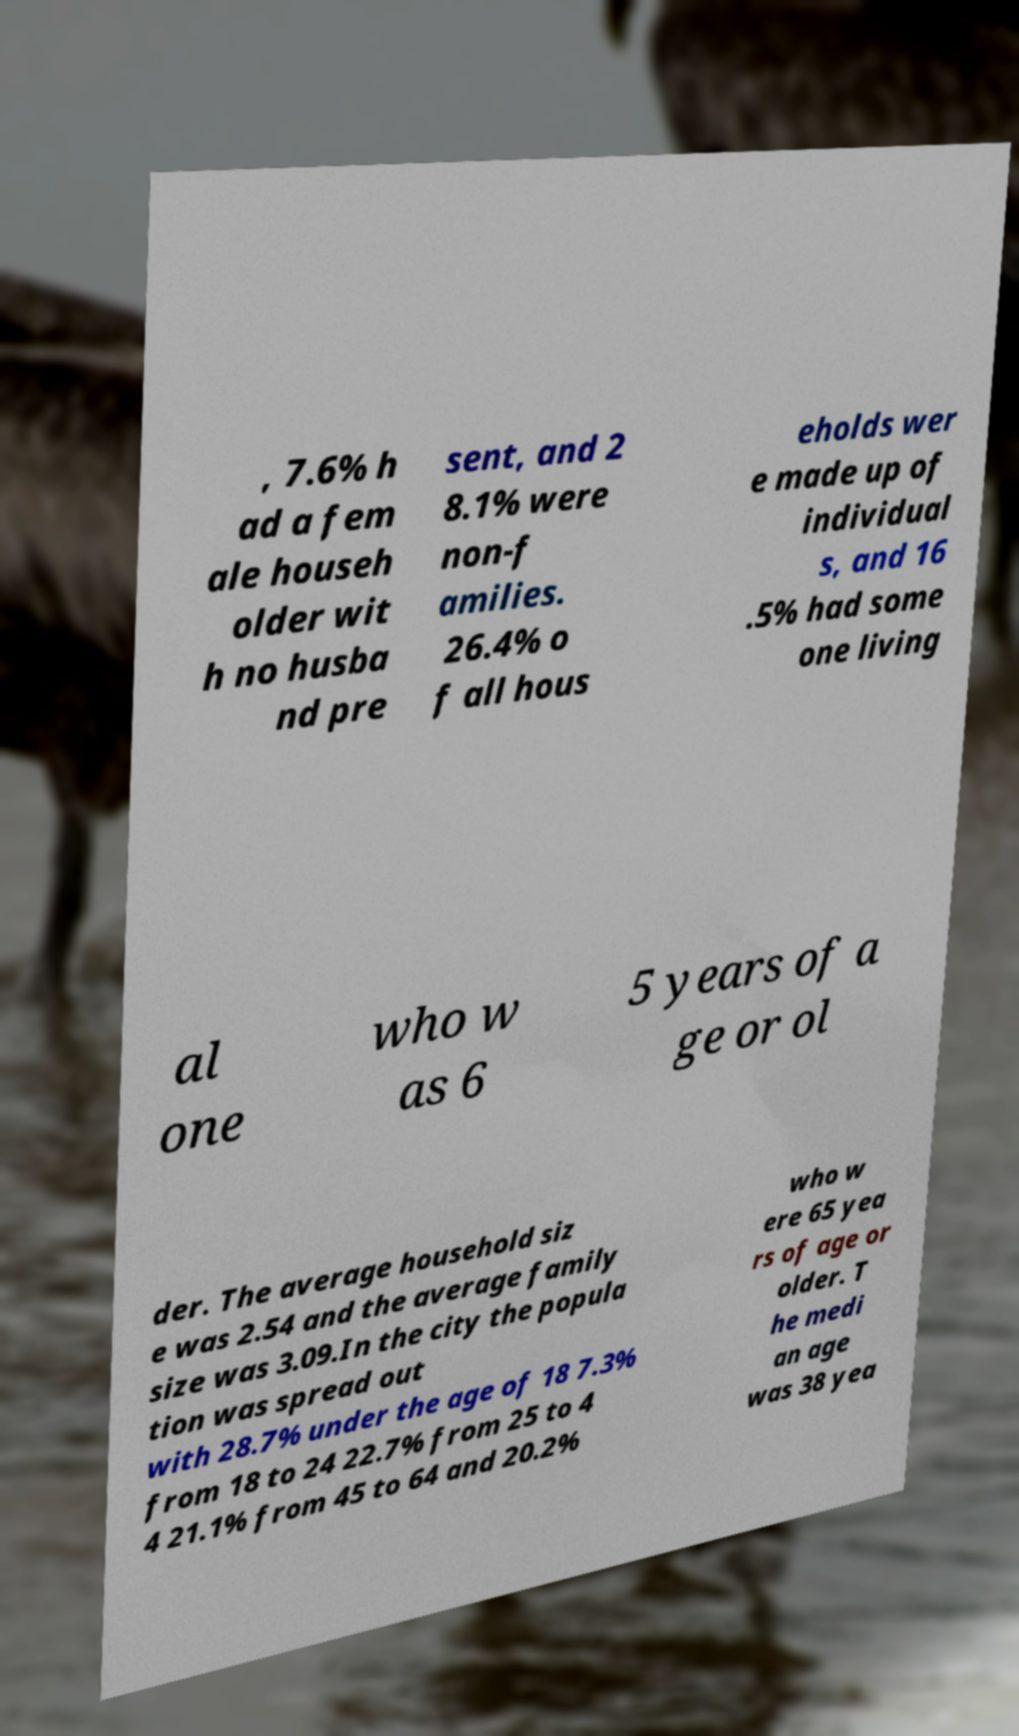Can you read and provide the text displayed in the image?This photo seems to have some interesting text. Can you extract and type it out for me? , 7.6% h ad a fem ale househ older wit h no husba nd pre sent, and 2 8.1% were non-f amilies. 26.4% o f all hous eholds wer e made up of individual s, and 16 .5% had some one living al one who w as 6 5 years of a ge or ol der. The average household siz e was 2.54 and the average family size was 3.09.In the city the popula tion was spread out with 28.7% under the age of 18 7.3% from 18 to 24 22.7% from 25 to 4 4 21.1% from 45 to 64 and 20.2% who w ere 65 yea rs of age or older. T he medi an age was 38 yea 